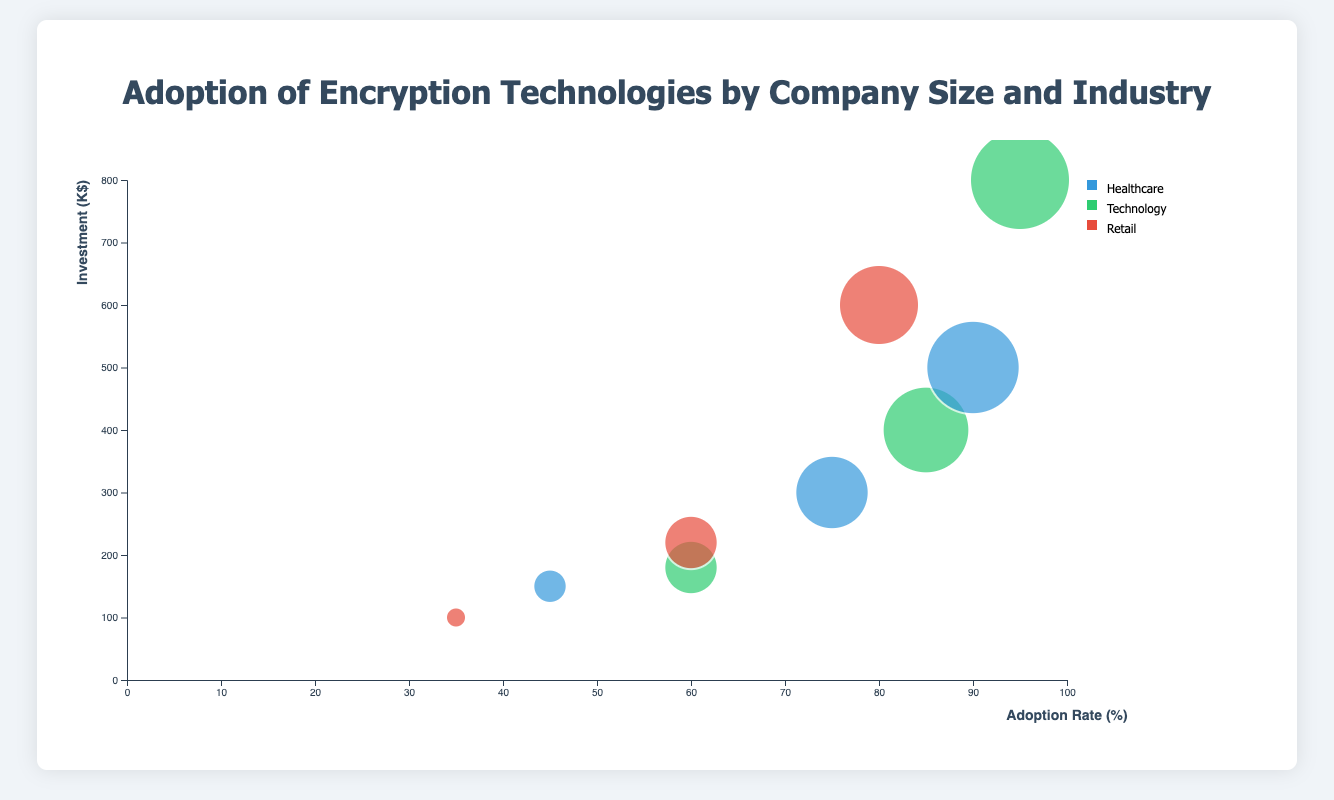What is the title of the chart? The title is displayed at the top center of the chart in large, bold font. It helps identify the main topic of the visualization.
Answer: Adoption of Encryption Technologies by Company Size and Industry How many industries are represented in the chart? Observing the legend on the right side of the chart, it lists the industries represented, each with its color code. There are three different colors representing three industries.
Answer: 3 Which industry shows the highest investment in encryption technologies for large companies? By looking at the bubbles for large companies, the bubble with the highest y-axis value (investment) belongs to the Technology industry, color-coded green, with the company "TechGiant".
Answer: Technology How does the adoption rate for small technology companies compare to small healthcare companies? Viewing the x-axis positions for small technology and small healthcare companies, "TechLaunch" has an adoption rate at 60% while "MediQuick" is at 45%.
Answer: Higher What is the investment difference in encryption technologies between medium healthcare and medium retail companies? Locate the medium-sized company bubbles for healthcare and retail. "HealthPro" (healthcare) has an investment of 300K, while "ValueMart" (retail) has an investment of 220K. Calculate the difference: 300 - 220 = 80.
Answer: 80K Which company has the smallest adoption rate, and what is it? Examine the bubbles and refer to the x-axis to find the company with the lowest adoption rate. "ShopEase" (Small, Retail) sits at 35%.
Answer: ShopEase, 35% In which industry and size category does the bubble with a radius representing an 85% adoption rate belong? By analyzing the bubble sizes and referencing the legend, the bubble with a radius corresponding to an 85% adoption rate belongs to the Medium-sized Technology industry, which is colored green, representing "InnovTech".
Answer: Medium, Technology What is the average investment in encryption technologies for medium-sized companies across all industries? Identify the investments for medium-sized companies: "HealthPro" (300), "InnovTech" (400), "ValueMart" (220). Sum them (300 + 400 + 220 = 920) and divide by 3. The average investment is 920 / 3 = 306.67.
Answer: 306.67K Which small company has the highest adoption rate and what is the rate? Refer to the bubbles corresponding to small companies and find the one with the highest x-axis value. The small company "TechLaunch" has the highest adoption rate at 60%.
Answer: TechLaunch, 60% Is there any bubble overlap? If so, which bubbles overlap the most? Visualize bubbles closely and detect overlapping ones by looking at placement and sizes. Small and Medium companies' bubbles within the same proximity, especially TechLaunch (Small, Technology) and ValueMart (Medium, Retail) might overlap due to their relative positions and sizes.
Answer: Yes, TechLaunch and ValueMart 